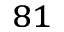<formula> <loc_0><loc_0><loc_500><loc_500>^ { 8 1 }</formula> 